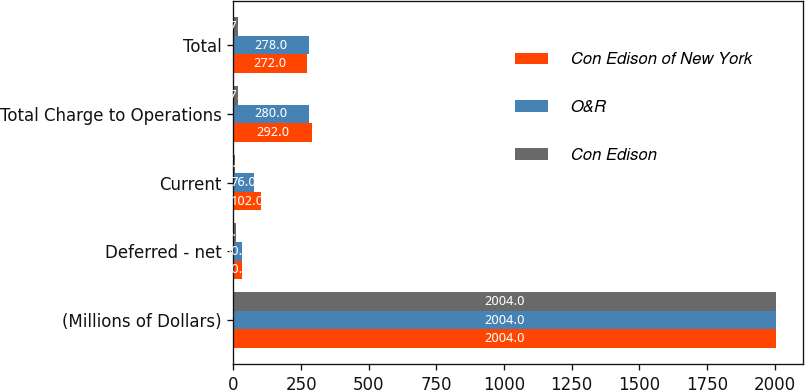Convert chart. <chart><loc_0><loc_0><loc_500><loc_500><stacked_bar_chart><ecel><fcel>(Millions of Dollars)<fcel>Deferred - net<fcel>Current<fcel>Total Charge to Operations<fcel>Total<nl><fcel>Con Edison of New York<fcel>2004<fcel>30<fcel>102<fcel>292<fcel>272<nl><fcel>O&R<fcel>2004<fcel>30<fcel>76<fcel>280<fcel>278<nl><fcel>Con Edison<fcel>2004<fcel>8<fcel>7<fcel>17<fcel>17<nl></chart> 